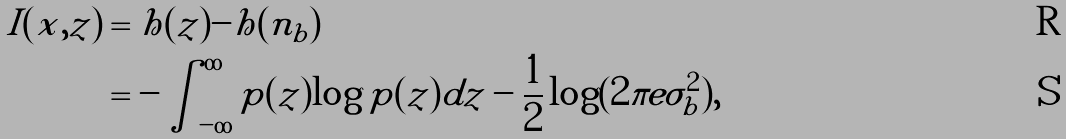Convert formula to latex. <formula><loc_0><loc_0><loc_500><loc_500>I ( x , z ) & = h ( z ) - h ( n _ { b } ) \\ & = - \int _ { - \infty } ^ { \infty } p ( z ) \log p ( z ) d z - \frac { 1 } { 2 } \log ( 2 \pi e \sigma _ { b } ^ { 2 } ) ,</formula> 